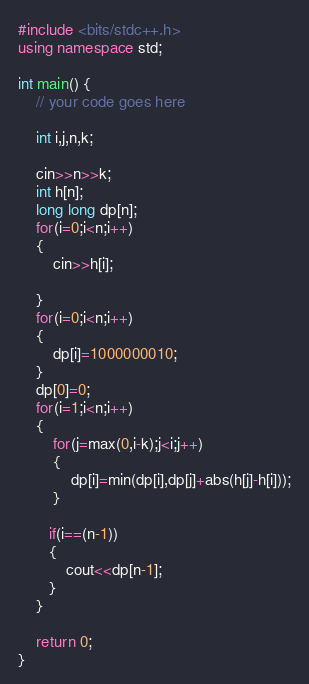Convert code to text. <code><loc_0><loc_0><loc_500><loc_500><_C++_>#include <bits/stdc++.h>
using namespace std;
 
int main() {
	// your code goes here
 
	int i,j,n,k;
 
	cin>>n>>k;
	int h[n];
	long long dp[n];
	for(i=0;i<n;i++)
	{
	    cin>>h[i];
 
	}
	for(i=0;i<n;i++)
	{
	    dp[i]=1000000010;
	}
	dp[0]=0;
	for(i=1;i<n;i++)
	{
	    for(j=max(0,i-k);j<i;j++)
	    {
	        dp[i]=min(dp[i],dp[j]+abs(h[j]-h[i]));
	    }
 
	   if(i==(n-1))
	   {
	       cout<<dp[n-1];
	   }
	}
 
	return 0;
}
</code> 